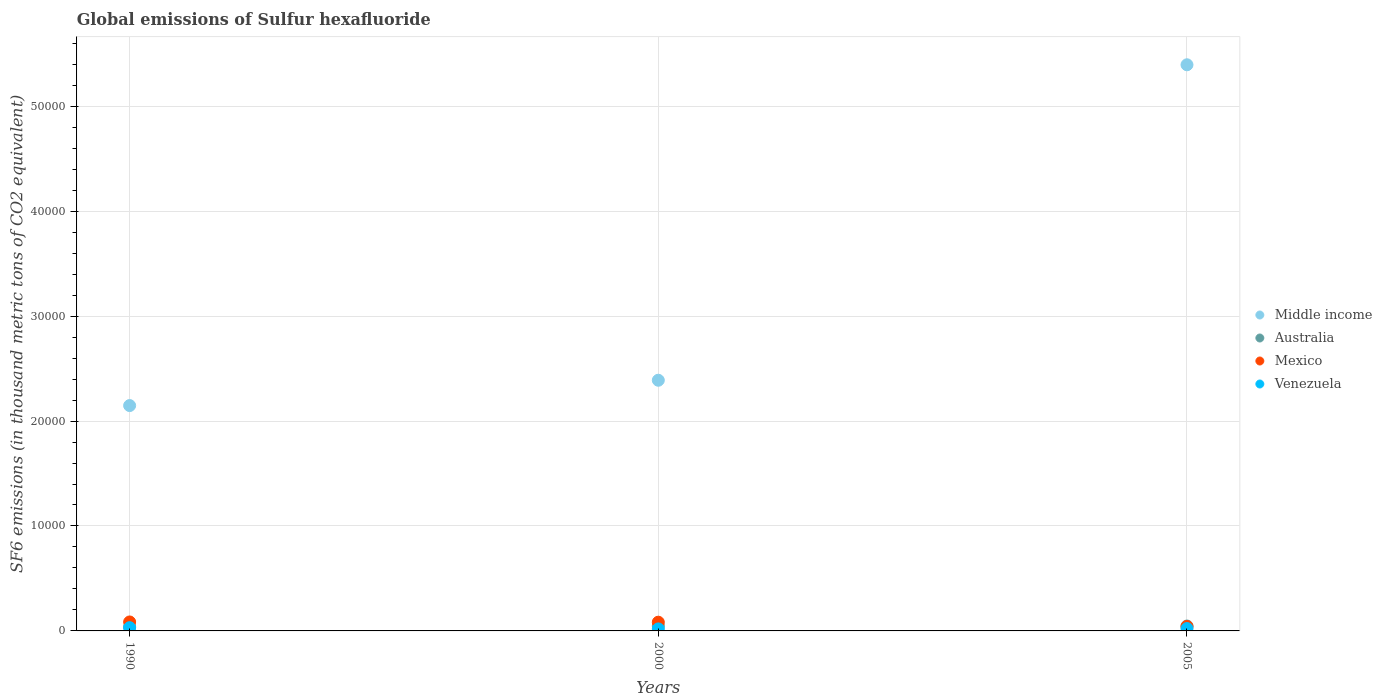Is the number of dotlines equal to the number of legend labels?
Your response must be concise. Yes. What is the global emissions of Sulfur hexafluoride in Mexico in 1990?
Your answer should be compact. 854.5. Across all years, what is the maximum global emissions of Sulfur hexafluoride in Middle income?
Your answer should be compact. 5.39e+04. Across all years, what is the minimum global emissions of Sulfur hexafluoride in Mexico?
Your answer should be very brief. 420.6. In which year was the global emissions of Sulfur hexafluoride in Mexico maximum?
Your response must be concise. 1990. What is the total global emissions of Sulfur hexafluoride in Australia in the graph?
Provide a short and direct response. 1322.9. What is the difference between the global emissions of Sulfur hexafluoride in Middle income in 2000 and that in 2005?
Give a very brief answer. -3.01e+04. What is the difference between the global emissions of Sulfur hexafluoride in Mexico in 2000 and the global emissions of Sulfur hexafluoride in Australia in 2005?
Keep it short and to the point. 365.2. What is the average global emissions of Sulfur hexafluoride in Mexico per year?
Keep it short and to the point. 702.3. In the year 2000, what is the difference between the global emissions of Sulfur hexafluoride in Middle income and global emissions of Sulfur hexafluoride in Venezuela?
Make the answer very short. 2.37e+04. In how many years, is the global emissions of Sulfur hexafluoride in Venezuela greater than 2000 thousand metric tons?
Provide a succinct answer. 0. What is the ratio of the global emissions of Sulfur hexafluoride in Venezuela in 2000 to that in 2005?
Ensure brevity in your answer.  0.85. Is the global emissions of Sulfur hexafluoride in Venezuela in 2000 less than that in 2005?
Provide a short and direct response. Yes. Is the difference between the global emissions of Sulfur hexafluoride in Middle income in 1990 and 2005 greater than the difference between the global emissions of Sulfur hexafluoride in Venezuela in 1990 and 2005?
Provide a succinct answer. No. What is the difference between the highest and the second highest global emissions of Sulfur hexafluoride in Middle income?
Your response must be concise. 3.01e+04. What is the difference between the highest and the lowest global emissions of Sulfur hexafluoride in Middle income?
Offer a very short reply. 3.25e+04. Is it the case that in every year, the sum of the global emissions of Sulfur hexafluoride in Mexico and global emissions of Sulfur hexafluoride in Venezuela  is greater than the global emissions of Sulfur hexafluoride in Australia?
Make the answer very short. Yes. How many dotlines are there?
Ensure brevity in your answer.  4. How many years are there in the graph?
Your answer should be very brief. 3. What is the difference between two consecutive major ticks on the Y-axis?
Keep it short and to the point. 10000. Does the graph contain grids?
Your response must be concise. Yes. Where does the legend appear in the graph?
Ensure brevity in your answer.  Center right. What is the title of the graph?
Provide a succinct answer. Global emissions of Sulfur hexafluoride. What is the label or title of the X-axis?
Provide a succinct answer. Years. What is the label or title of the Y-axis?
Keep it short and to the point. SF6 emissions (in thousand metric tons of CO2 equivalent). What is the SF6 emissions (in thousand metric tons of CO2 equivalent) of Middle income in 1990?
Provide a short and direct response. 2.15e+04. What is the SF6 emissions (in thousand metric tons of CO2 equivalent) of Australia in 1990?
Keep it short and to the point. 385.1. What is the SF6 emissions (in thousand metric tons of CO2 equivalent) of Mexico in 1990?
Your answer should be compact. 854.5. What is the SF6 emissions (in thousand metric tons of CO2 equivalent) in Venezuela in 1990?
Provide a short and direct response. 309.8. What is the SF6 emissions (in thousand metric tons of CO2 equivalent) in Middle income in 2000?
Ensure brevity in your answer.  2.39e+04. What is the SF6 emissions (in thousand metric tons of CO2 equivalent) in Australia in 2000?
Your response must be concise. 471.2. What is the SF6 emissions (in thousand metric tons of CO2 equivalent) of Mexico in 2000?
Make the answer very short. 831.8. What is the SF6 emissions (in thousand metric tons of CO2 equivalent) of Venezuela in 2000?
Make the answer very short. 191.4. What is the SF6 emissions (in thousand metric tons of CO2 equivalent) in Middle income in 2005?
Provide a short and direct response. 5.39e+04. What is the SF6 emissions (in thousand metric tons of CO2 equivalent) of Australia in 2005?
Ensure brevity in your answer.  466.6. What is the SF6 emissions (in thousand metric tons of CO2 equivalent) of Mexico in 2005?
Provide a succinct answer. 420.6. What is the SF6 emissions (in thousand metric tons of CO2 equivalent) of Venezuela in 2005?
Provide a succinct answer. 225.1. Across all years, what is the maximum SF6 emissions (in thousand metric tons of CO2 equivalent) in Middle income?
Give a very brief answer. 5.39e+04. Across all years, what is the maximum SF6 emissions (in thousand metric tons of CO2 equivalent) in Australia?
Keep it short and to the point. 471.2. Across all years, what is the maximum SF6 emissions (in thousand metric tons of CO2 equivalent) in Mexico?
Your answer should be compact. 854.5. Across all years, what is the maximum SF6 emissions (in thousand metric tons of CO2 equivalent) in Venezuela?
Provide a succinct answer. 309.8. Across all years, what is the minimum SF6 emissions (in thousand metric tons of CO2 equivalent) of Middle income?
Give a very brief answer. 2.15e+04. Across all years, what is the minimum SF6 emissions (in thousand metric tons of CO2 equivalent) in Australia?
Make the answer very short. 385.1. Across all years, what is the minimum SF6 emissions (in thousand metric tons of CO2 equivalent) of Mexico?
Ensure brevity in your answer.  420.6. Across all years, what is the minimum SF6 emissions (in thousand metric tons of CO2 equivalent) in Venezuela?
Keep it short and to the point. 191.4. What is the total SF6 emissions (in thousand metric tons of CO2 equivalent) in Middle income in the graph?
Keep it short and to the point. 9.93e+04. What is the total SF6 emissions (in thousand metric tons of CO2 equivalent) in Australia in the graph?
Make the answer very short. 1322.9. What is the total SF6 emissions (in thousand metric tons of CO2 equivalent) in Mexico in the graph?
Provide a succinct answer. 2106.9. What is the total SF6 emissions (in thousand metric tons of CO2 equivalent) of Venezuela in the graph?
Keep it short and to the point. 726.3. What is the difference between the SF6 emissions (in thousand metric tons of CO2 equivalent) of Middle income in 1990 and that in 2000?
Provide a succinct answer. -2413.4. What is the difference between the SF6 emissions (in thousand metric tons of CO2 equivalent) in Australia in 1990 and that in 2000?
Make the answer very short. -86.1. What is the difference between the SF6 emissions (in thousand metric tons of CO2 equivalent) in Mexico in 1990 and that in 2000?
Give a very brief answer. 22.7. What is the difference between the SF6 emissions (in thousand metric tons of CO2 equivalent) in Venezuela in 1990 and that in 2000?
Provide a short and direct response. 118.4. What is the difference between the SF6 emissions (in thousand metric tons of CO2 equivalent) of Middle income in 1990 and that in 2005?
Your answer should be compact. -3.25e+04. What is the difference between the SF6 emissions (in thousand metric tons of CO2 equivalent) of Australia in 1990 and that in 2005?
Offer a terse response. -81.5. What is the difference between the SF6 emissions (in thousand metric tons of CO2 equivalent) in Mexico in 1990 and that in 2005?
Provide a succinct answer. 433.9. What is the difference between the SF6 emissions (in thousand metric tons of CO2 equivalent) of Venezuela in 1990 and that in 2005?
Make the answer very short. 84.7. What is the difference between the SF6 emissions (in thousand metric tons of CO2 equivalent) of Middle income in 2000 and that in 2005?
Keep it short and to the point. -3.01e+04. What is the difference between the SF6 emissions (in thousand metric tons of CO2 equivalent) of Mexico in 2000 and that in 2005?
Your answer should be very brief. 411.2. What is the difference between the SF6 emissions (in thousand metric tons of CO2 equivalent) of Venezuela in 2000 and that in 2005?
Offer a very short reply. -33.7. What is the difference between the SF6 emissions (in thousand metric tons of CO2 equivalent) in Middle income in 1990 and the SF6 emissions (in thousand metric tons of CO2 equivalent) in Australia in 2000?
Offer a very short reply. 2.10e+04. What is the difference between the SF6 emissions (in thousand metric tons of CO2 equivalent) in Middle income in 1990 and the SF6 emissions (in thousand metric tons of CO2 equivalent) in Mexico in 2000?
Keep it short and to the point. 2.06e+04. What is the difference between the SF6 emissions (in thousand metric tons of CO2 equivalent) of Middle income in 1990 and the SF6 emissions (in thousand metric tons of CO2 equivalent) of Venezuela in 2000?
Offer a terse response. 2.13e+04. What is the difference between the SF6 emissions (in thousand metric tons of CO2 equivalent) of Australia in 1990 and the SF6 emissions (in thousand metric tons of CO2 equivalent) of Mexico in 2000?
Provide a succinct answer. -446.7. What is the difference between the SF6 emissions (in thousand metric tons of CO2 equivalent) in Australia in 1990 and the SF6 emissions (in thousand metric tons of CO2 equivalent) in Venezuela in 2000?
Keep it short and to the point. 193.7. What is the difference between the SF6 emissions (in thousand metric tons of CO2 equivalent) of Mexico in 1990 and the SF6 emissions (in thousand metric tons of CO2 equivalent) of Venezuela in 2000?
Give a very brief answer. 663.1. What is the difference between the SF6 emissions (in thousand metric tons of CO2 equivalent) in Middle income in 1990 and the SF6 emissions (in thousand metric tons of CO2 equivalent) in Australia in 2005?
Make the answer very short. 2.10e+04. What is the difference between the SF6 emissions (in thousand metric tons of CO2 equivalent) in Middle income in 1990 and the SF6 emissions (in thousand metric tons of CO2 equivalent) in Mexico in 2005?
Ensure brevity in your answer.  2.11e+04. What is the difference between the SF6 emissions (in thousand metric tons of CO2 equivalent) in Middle income in 1990 and the SF6 emissions (in thousand metric tons of CO2 equivalent) in Venezuela in 2005?
Provide a succinct answer. 2.12e+04. What is the difference between the SF6 emissions (in thousand metric tons of CO2 equivalent) of Australia in 1990 and the SF6 emissions (in thousand metric tons of CO2 equivalent) of Mexico in 2005?
Your answer should be compact. -35.5. What is the difference between the SF6 emissions (in thousand metric tons of CO2 equivalent) of Australia in 1990 and the SF6 emissions (in thousand metric tons of CO2 equivalent) of Venezuela in 2005?
Provide a succinct answer. 160. What is the difference between the SF6 emissions (in thousand metric tons of CO2 equivalent) in Mexico in 1990 and the SF6 emissions (in thousand metric tons of CO2 equivalent) in Venezuela in 2005?
Keep it short and to the point. 629.4. What is the difference between the SF6 emissions (in thousand metric tons of CO2 equivalent) in Middle income in 2000 and the SF6 emissions (in thousand metric tons of CO2 equivalent) in Australia in 2005?
Offer a very short reply. 2.34e+04. What is the difference between the SF6 emissions (in thousand metric tons of CO2 equivalent) in Middle income in 2000 and the SF6 emissions (in thousand metric tons of CO2 equivalent) in Mexico in 2005?
Offer a terse response. 2.35e+04. What is the difference between the SF6 emissions (in thousand metric tons of CO2 equivalent) in Middle income in 2000 and the SF6 emissions (in thousand metric tons of CO2 equivalent) in Venezuela in 2005?
Your answer should be compact. 2.37e+04. What is the difference between the SF6 emissions (in thousand metric tons of CO2 equivalent) of Australia in 2000 and the SF6 emissions (in thousand metric tons of CO2 equivalent) of Mexico in 2005?
Offer a terse response. 50.6. What is the difference between the SF6 emissions (in thousand metric tons of CO2 equivalent) in Australia in 2000 and the SF6 emissions (in thousand metric tons of CO2 equivalent) in Venezuela in 2005?
Offer a very short reply. 246.1. What is the difference between the SF6 emissions (in thousand metric tons of CO2 equivalent) of Mexico in 2000 and the SF6 emissions (in thousand metric tons of CO2 equivalent) of Venezuela in 2005?
Your answer should be very brief. 606.7. What is the average SF6 emissions (in thousand metric tons of CO2 equivalent) in Middle income per year?
Your answer should be very brief. 3.31e+04. What is the average SF6 emissions (in thousand metric tons of CO2 equivalent) in Australia per year?
Make the answer very short. 440.97. What is the average SF6 emissions (in thousand metric tons of CO2 equivalent) in Mexico per year?
Your answer should be very brief. 702.3. What is the average SF6 emissions (in thousand metric tons of CO2 equivalent) of Venezuela per year?
Your answer should be compact. 242.1. In the year 1990, what is the difference between the SF6 emissions (in thousand metric tons of CO2 equivalent) of Middle income and SF6 emissions (in thousand metric tons of CO2 equivalent) of Australia?
Offer a very short reply. 2.11e+04. In the year 1990, what is the difference between the SF6 emissions (in thousand metric tons of CO2 equivalent) of Middle income and SF6 emissions (in thousand metric tons of CO2 equivalent) of Mexico?
Your answer should be very brief. 2.06e+04. In the year 1990, what is the difference between the SF6 emissions (in thousand metric tons of CO2 equivalent) of Middle income and SF6 emissions (in thousand metric tons of CO2 equivalent) of Venezuela?
Your response must be concise. 2.12e+04. In the year 1990, what is the difference between the SF6 emissions (in thousand metric tons of CO2 equivalent) of Australia and SF6 emissions (in thousand metric tons of CO2 equivalent) of Mexico?
Offer a very short reply. -469.4. In the year 1990, what is the difference between the SF6 emissions (in thousand metric tons of CO2 equivalent) of Australia and SF6 emissions (in thousand metric tons of CO2 equivalent) of Venezuela?
Ensure brevity in your answer.  75.3. In the year 1990, what is the difference between the SF6 emissions (in thousand metric tons of CO2 equivalent) in Mexico and SF6 emissions (in thousand metric tons of CO2 equivalent) in Venezuela?
Provide a short and direct response. 544.7. In the year 2000, what is the difference between the SF6 emissions (in thousand metric tons of CO2 equivalent) in Middle income and SF6 emissions (in thousand metric tons of CO2 equivalent) in Australia?
Your answer should be very brief. 2.34e+04. In the year 2000, what is the difference between the SF6 emissions (in thousand metric tons of CO2 equivalent) of Middle income and SF6 emissions (in thousand metric tons of CO2 equivalent) of Mexico?
Provide a short and direct response. 2.31e+04. In the year 2000, what is the difference between the SF6 emissions (in thousand metric tons of CO2 equivalent) in Middle income and SF6 emissions (in thousand metric tons of CO2 equivalent) in Venezuela?
Offer a terse response. 2.37e+04. In the year 2000, what is the difference between the SF6 emissions (in thousand metric tons of CO2 equivalent) of Australia and SF6 emissions (in thousand metric tons of CO2 equivalent) of Mexico?
Provide a short and direct response. -360.6. In the year 2000, what is the difference between the SF6 emissions (in thousand metric tons of CO2 equivalent) in Australia and SF6 emissions (in thousand metric tons of CO2 equivalent) in Venezuela?
Offer a very short reply. 279.8. In the year 2000, what is the difference between the SF6 emissions (in thousand metric tons of CO2 equivalent) in Mexico and SF6 emissions (in thousand metric tons of CO2 equivalent) in Venezuela?
Make the answer very short. 640.4. In the year 2005, what is the difference between the SF6 emissions (in thousand metric tons of CO2 equivalent) in Middle income and SF6 emissions (in thousand metric tons of CO2 equivalent) in Australia?
Your answer should be compact. 5.35e+04. In the year 2005, what is the difference between the SF6 emissions (in thousand metric tons of CO2 equivalent) in Middle income and SF6 emissions (in thousand metric tons of CO2 equivalent) in Mexico?
Your answer should be very brief. 5.35e+04. In the year 2005, what is the difference between the SF6 emissions (in thousand metric tons of CO2 equivalent) in Middle income and SF6 emissions (in thousand metric tons of CO2 equivalent) in Venezuela?
Provide a succinct answer. 5.37e+04. In the year 2005, what is the difference between the SF6 emissions (in thousand metric tons of CO2 equivalent) in Australia and SF6 emissions (in thousand metric tons of CO2 equivalent) in Mexico?
Give a very brief answer. 46. In the year 2005, what is the difference between the SF6 emissions (in thousand metric tons of CO2 equivalent) of Australia and SF6 emissions (in thousand metric tons of CO2 equivalent) of Venezuela?
Offer a very short reply. 241.5. In the year 2005, what is the difference between the SF6 emissions (in thousand metric tons of CO2 equivalent) in Mexico and SF6 emissions (in thousand metric tons of CO2 equivalent) in Venezuela?
Offer a very short reply. 195.5. What is the ratio of the SF6 emissions (in thousand metric tons of CO2 equivalent) in Middle income in 1990 to that in 2000?
Your answer should be very brief. 0.9. What is the ratio of the SF6 emissions (in thousand metric tons of CO2 equivalent) of Australia in 1990 to that in 2000?
Keep it short and to the point. 0.82. What is the ratio of the SF6 emissions (in thousand metric tons of CO2 equivalent) in Mexico in 1990 to that in 2000?
Your answer should be very brief. 1.03. What is the ratio of the SF6 emissions (in thousand metric tons of CO2 equivalent) in Venezuela in 1990 to that in 2000?
Provide a short and direct response. 1.62. What is the ratio of the SF6 emissions (in thousand metric tons of CO2 equivalent) in Middle income in 1990 to that in 2005?
Your answer should be compact. 0.4. What is the ratio of the SF6 emissions (in thousand metric tons of CO2 equivalent) of Australia in 1990 to that in 2005?
Your answer should be very brief. 0.83. What is the ratio of the SF6 emissions (in thousand metric tons of CO2 equivalent) of Mexico in 1990 to that in 2005?
Your answer should be very brief. 2.03. What is the ratio of the SF6 emissions (in thousand metric tons of CO2 equivalent) of Venezuela in 1990 to that in 2005?
Offer a terse response. 1.38. What is the ratio of the SF6 emissions (in thousand metric tons of CO2 equivalent) of Middle income in 2000 to that in 2005?
Your response must be concise. 0.44. What is the ratio of the SF6 emissions (in thousand metric tons of CO2 equivalent) of Australia in 2000 to that in 2005?
Your response must be concise. 1.01. What is the ratio of the SF6 emissions (in thousand metric tons of CO2 equivalent) in Mexico in 2000 to that in 2005?
Make the answer very short. 1.98. What is the ratio of the SF6 emissions (in thousand metric tons of CO2 equivalent) in Venezuela in 2000 to that in 2005?
Give a very brief answer. 0.85. What is the difference between the highest and the second highest SF6 emissions (in thousand metric tons of CO2 equivalent) of Middle income?
Ensure brevity in your answer.  3.01e+04. What is the difference between the highest and the second highest SF6 emissions (in thousand metric tons of CO2 equivalent) in Mexico?
Offer a terse response. 22.7. What is the difference between the highest and the second highest SF6 emissions (in thousand metric tons of CO2 equivalent) in Venezuela?
Offer a terse response. 84.7. What is the difference between the highest and the lowest SF6 emissions (in thousand metric tons of CO2 equivalent) of Middle income?
Keep it short and to the point. 3.25e+04. What is the difference between the highest and the lowest SF6 emissions (in thousand metric tons of CO2 equivalent) in Australia?
Provide a succinct answer. 86.1. What is the difference between the highest and the lowest SF6 emissions (in thousand metric tons of CO2 equivalent) in Mexico?
Your response must be concise. 433.9. What is the difference between the highest and the lowest SF6 emissions (in thousand metric tons of CO2 equivalent) of Venezuela?
Provide a short and direct response. 118.4. 